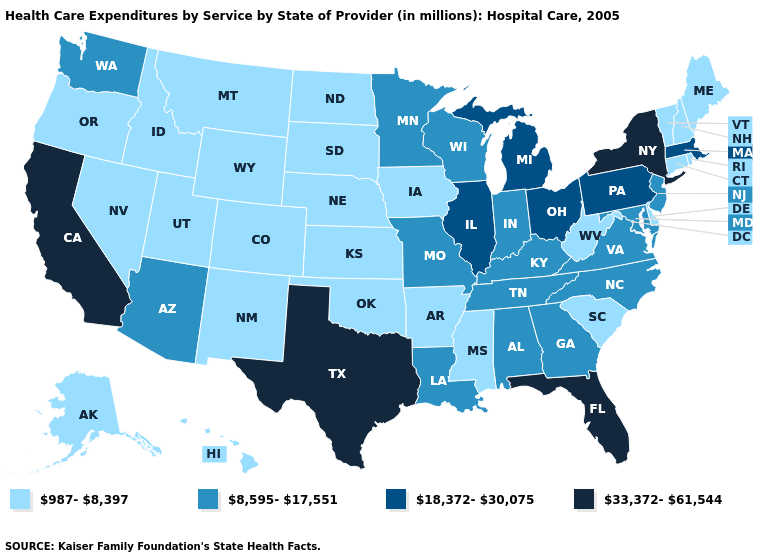What is the lowest value in states that border Ohio?
Be succinct. 987-8,397. How many symbols are there in the legend?
Be succinct. 4. What is the highest value in states that border Colorado?
Short answer required. 8,595-17,551. What is the highest value in states that border Nebraska?
Quick response, please. 8,595-17,551. What is the highest value in the USA?
Write a very short answer. 33,372-61,544. Is the legend a continuous bar?
Be succinct. No. Among the states that border North Carolina , which have the highest value?
Quick response, please. Georgia, Tennessee, Virginia. Among the states that border Illinois , does Missouri have the lowest value?
Write a very short answer. No. What is the lowest value in states that border Vermont?
Quick response, please. 987-8,397. What is the value of Pennsylvania?
Write a very short answer. 18,372-30,075. What is the highest value in the USA?
Keep it brief. 33,372-61,544. Which states have the lowest value in the USA?
Concise answer only. Alaska, Arkansas, Colorado, Connecticut, Delaware, Hawaii, Idaho, Iowa, Kansas, Maine, Mississippi, Montana, Nebraska, Nevada, New Hampshire, New Mexico, North Dakota, Oklahoma, Oregon, Rhode Island, South Carolina, South Dakota, Utah, Vermont, West Virginia, Wyoming. Does the first symbol in the legend represent the smallest category?
Write a very short answer. Yes. What is the value of Colorado?
Write a very short answer. 987-8,397. Name the states that have a value in the range 18,372-30,075?
Quick response, please. Illinois, Massachusetts, Michigan, Ohio, Pennsylvania. 